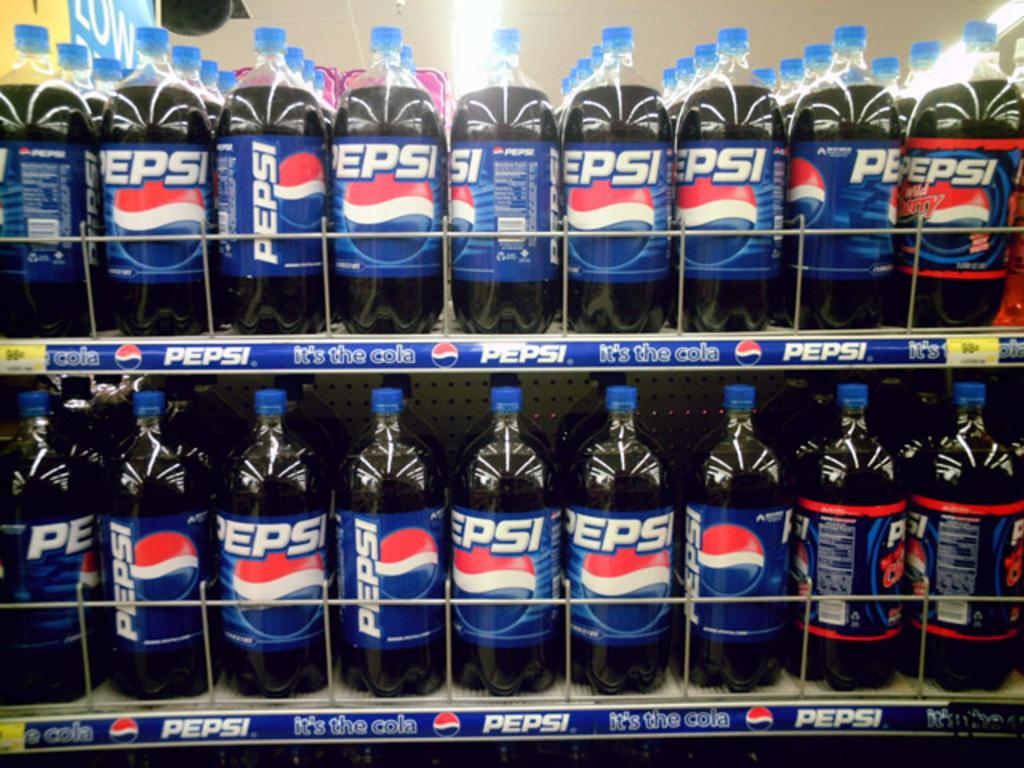What type of drink is contained in the bottles in the image? The bottles contain Pepsi juice in the image. Where are the bottles located? The bottles are placed on a shelf in the image. Is there any quicksand visible in the image? No, there is no quicksand present in the image. What type of snack is being served with the Pepsi juice in the image? The image does not show any snacks, such as popcorn or celery, being served with the Pepsi juice. 